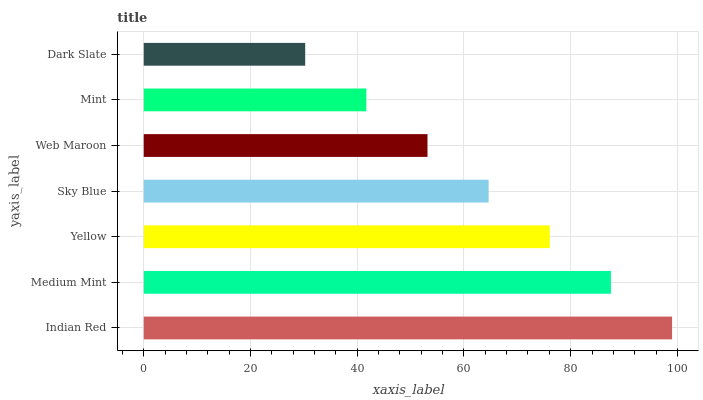Is Dark Slate the minimum?
Answer yes or no. Yes. Is Indian Red the maximum?
Answer yes or no. Yes. Is Medium Mint the minimum?
Answer yes or no. No. Is Medium Mint the maximum?
Answer yes or no. No. Is Indian Red greater than Medium Mint?
Answer yes or no. Yes. Is Medium Mint less than Indian Red?
Answer yes or no. Yes. Is Medium Mint greater than Indian Red?
Answer yes or no. No. Is Indian Red less than Medium Mint?
Answer yes or no. No. Is Sky Blue the high median?
Answer yes or no. Yes. Is Sky Blue the low median?
Answer yes or no. Yes. Is Mint the high median?
Answer yes or no. No. Is Yellow the low median?
Answer yes or no. No. 